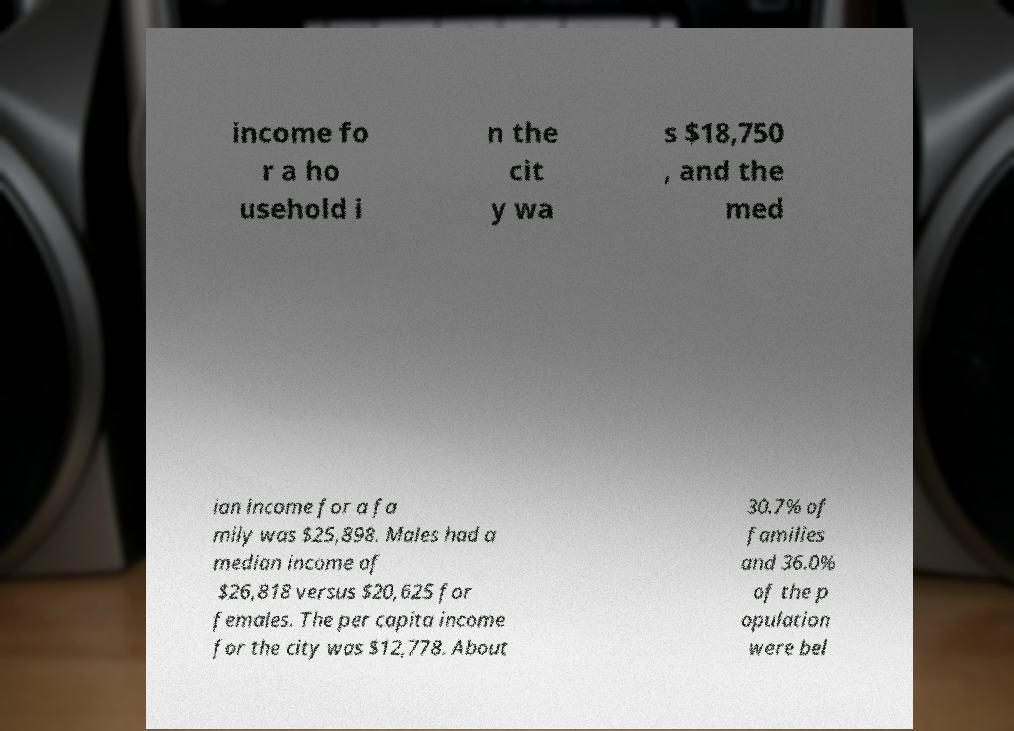Please identify and transcribe the text found in this image. income fo r a ho usehold i n the cit y wa s $18,750 , and the med ian income for a fa mily was $25,898. Males had a median income of $26,818 versus $20,625 for females. The per capita income for the city was $12,778. About 30.7% of families and 36.0% of the p opulation were bel 